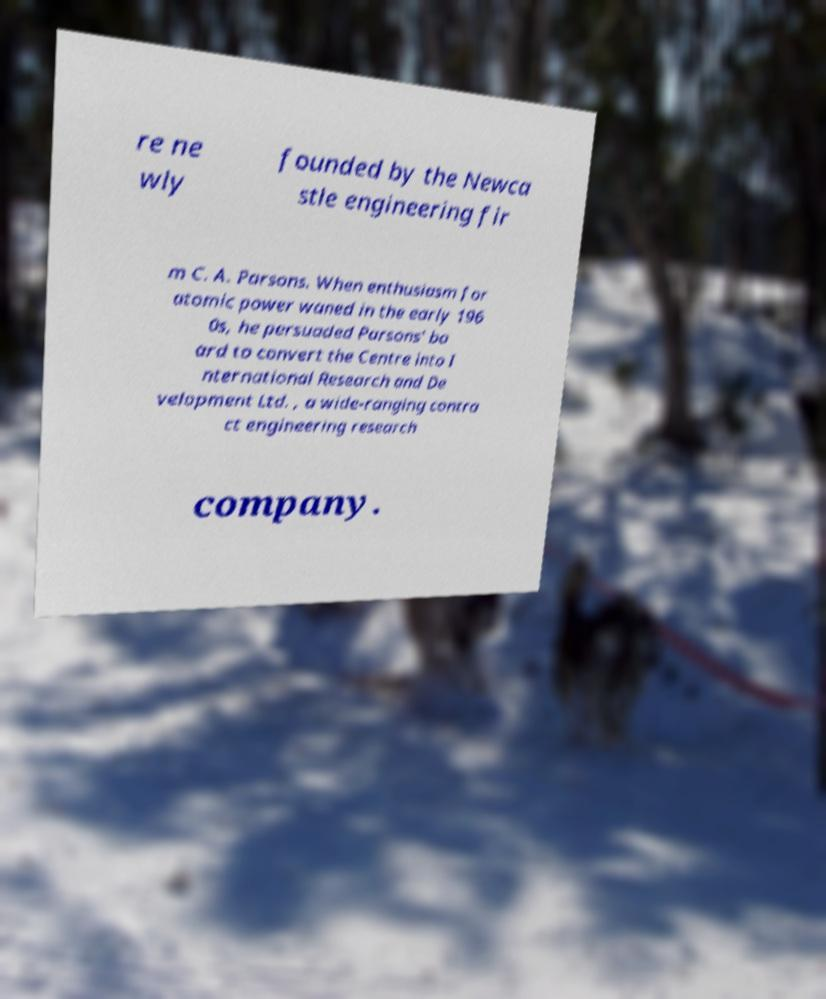Can you accurately transcribe the text from the provided image for me? re ne wly founded by the Newca stle engineering fir m C. A. Parsons. When enthusiasm for atomic power waned in the early 196 0s, he persuaded Parsons' bo ard to convert the Centre into I nternational Research and De velopment Ltd. , a wide-ranging contra ct engineering research company. 